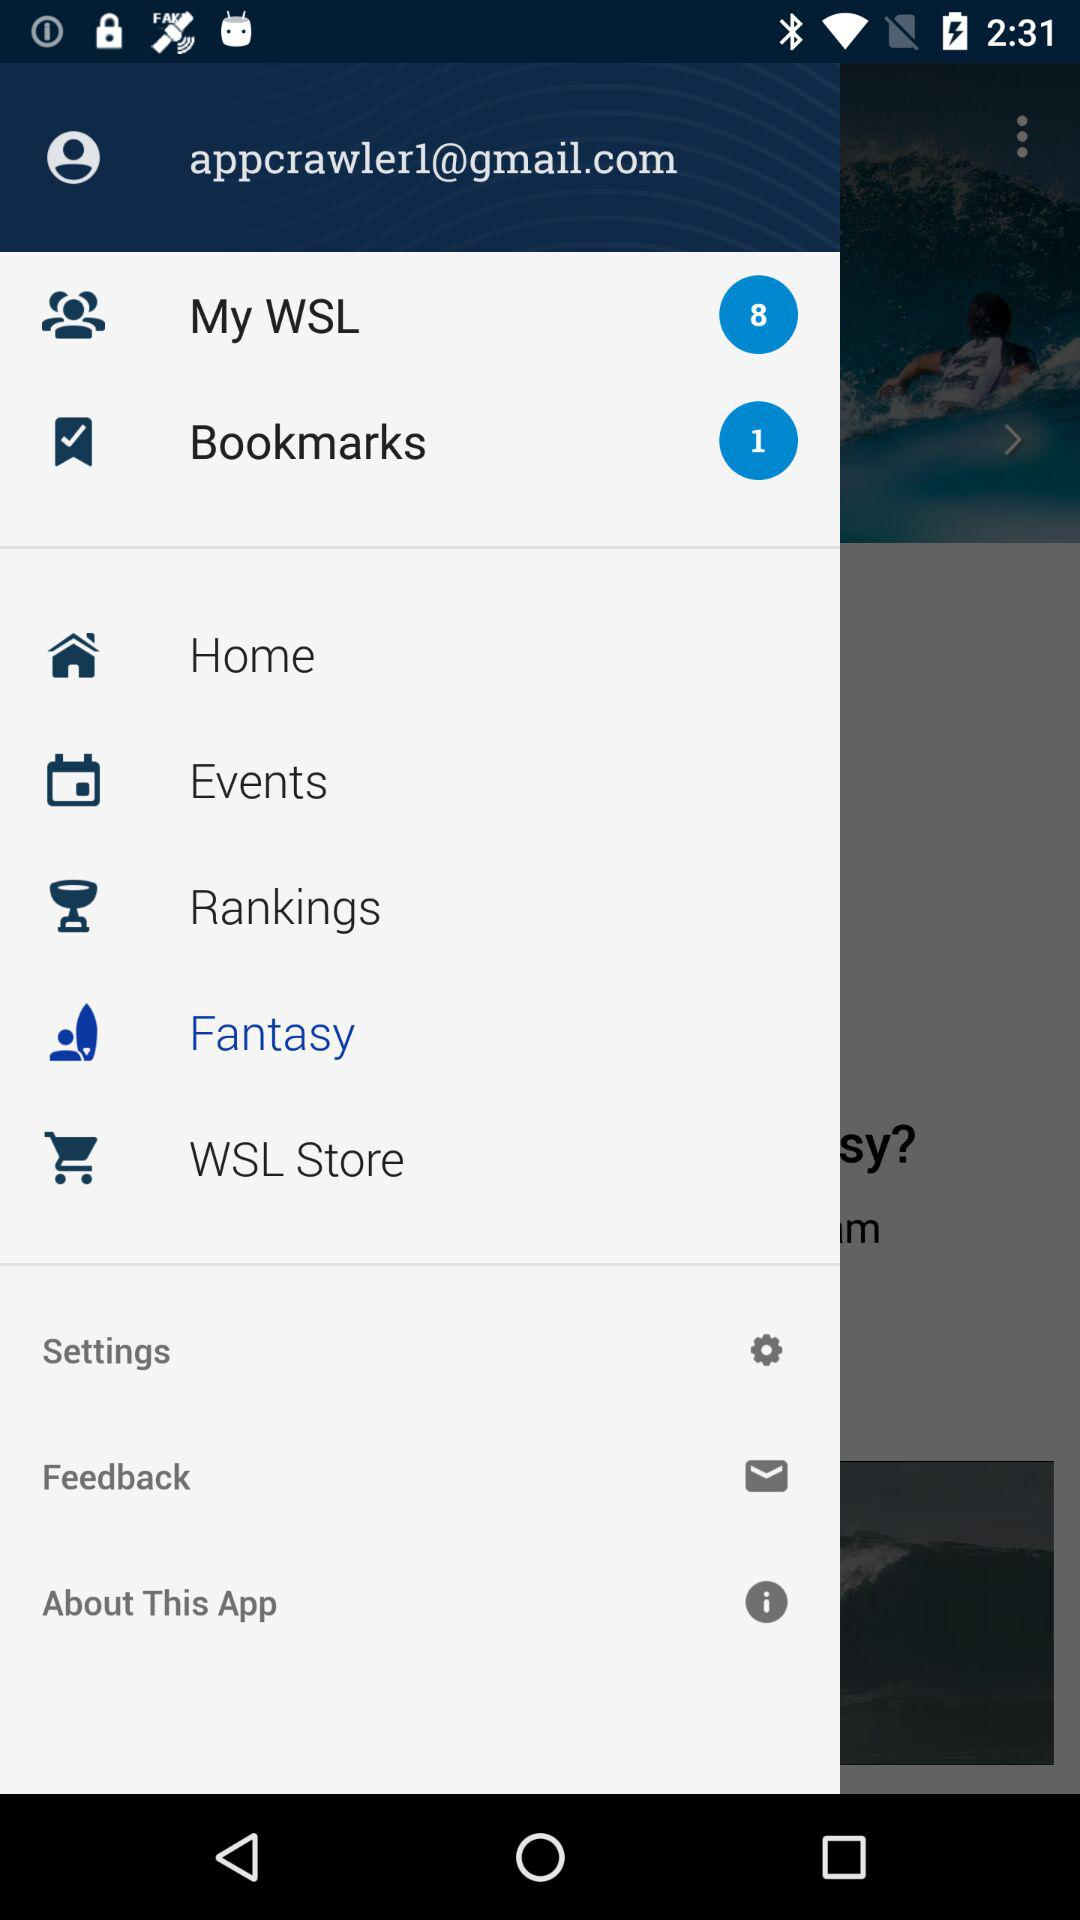What is the email address? The email address is appcrawler1@gmail.com. 